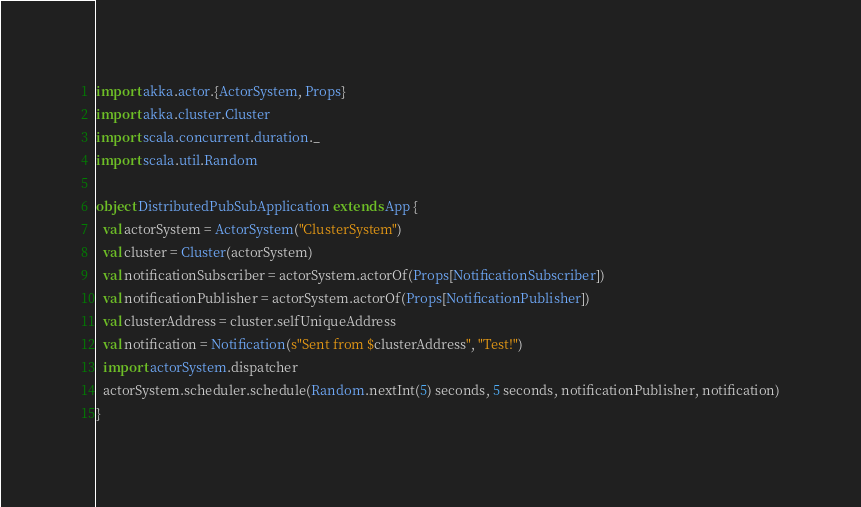<code> <loc_0><loc_0><loc_500><loc_500><_Scala_>import akka.actor.{ActorSystem, Props}
import akka.cluster.Cluster
import scala.concurrent.duration._
import scala.util.Random

object DistributedPubSubApplication extends App {
  val actorSystem = ActorSystem("ClusterSystem")
  val cluster = Cluster(actorSystem)
  val notificationSubscriber = actorSystem.actorOf(Props[NotificationSubscriber])
  val notificationPublisher = actorSystem.actorOf(Props[NotificationPublisher])
  val clusterAddress = cluster.selfUniqueAddress
  val notification = Notification(s"Sent from $clusterAddress", "Test!")
  import actorSystem.dispatcher
  actorSystem.scheduler.schedule(Random.nextInt(5) seconds, 5 seconds, notificationPublisher, notification)
}
</code> 